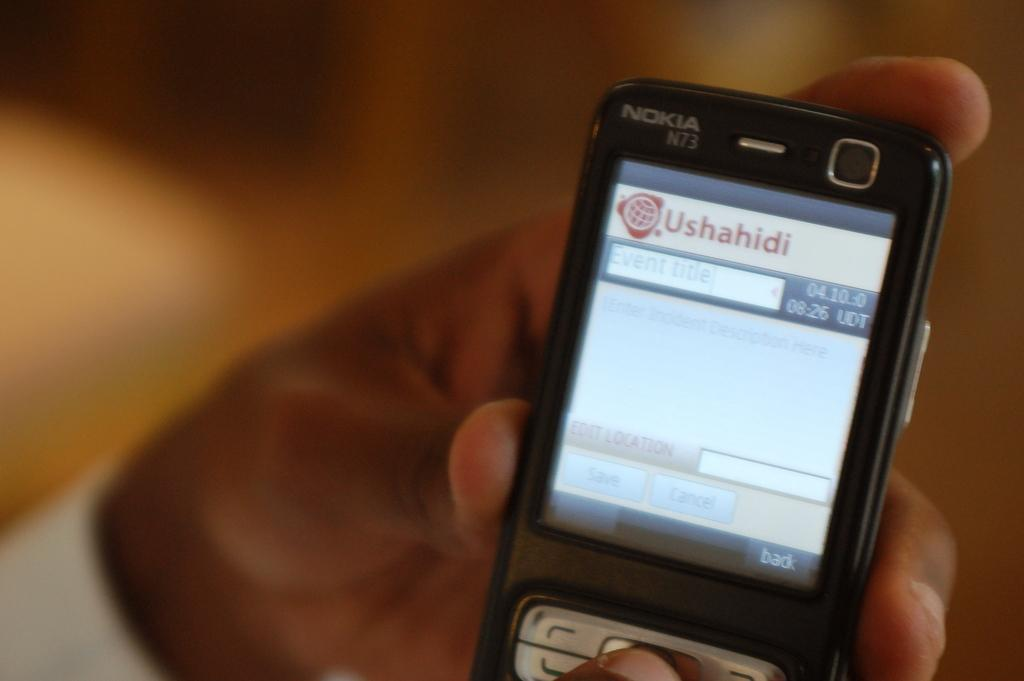<image>
Share a concise interpretation of the image provided. The cell phone that a hand is holding was made by Nokia. 